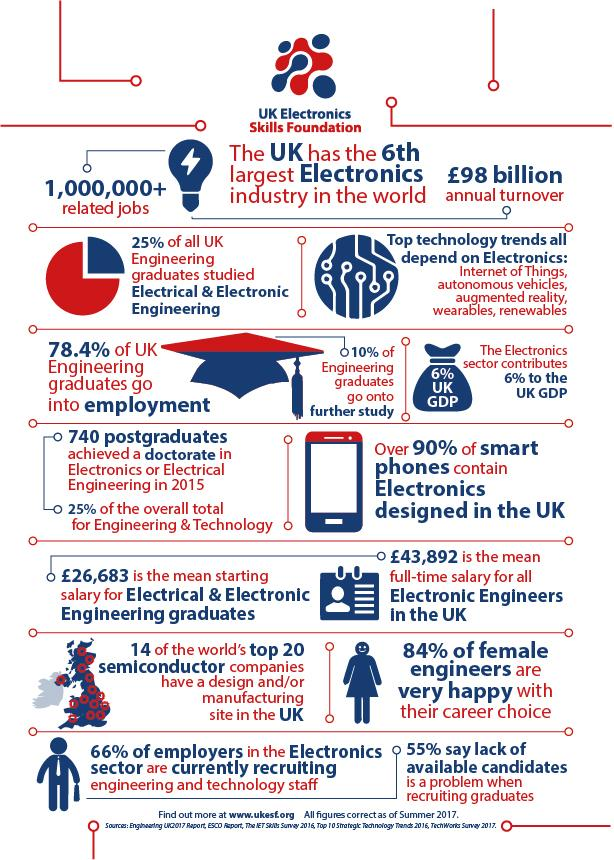Give some essential details in this illustration. A significant proportion of electronics engineers in the UK choose to pursue higher education, with approximately 10% of them enrolling in postgraduate programs or continuing their education through professional development courses. According to 66%, 84%, and 55% of employers, there is a shortage of an educated workforce in the electronics field. 